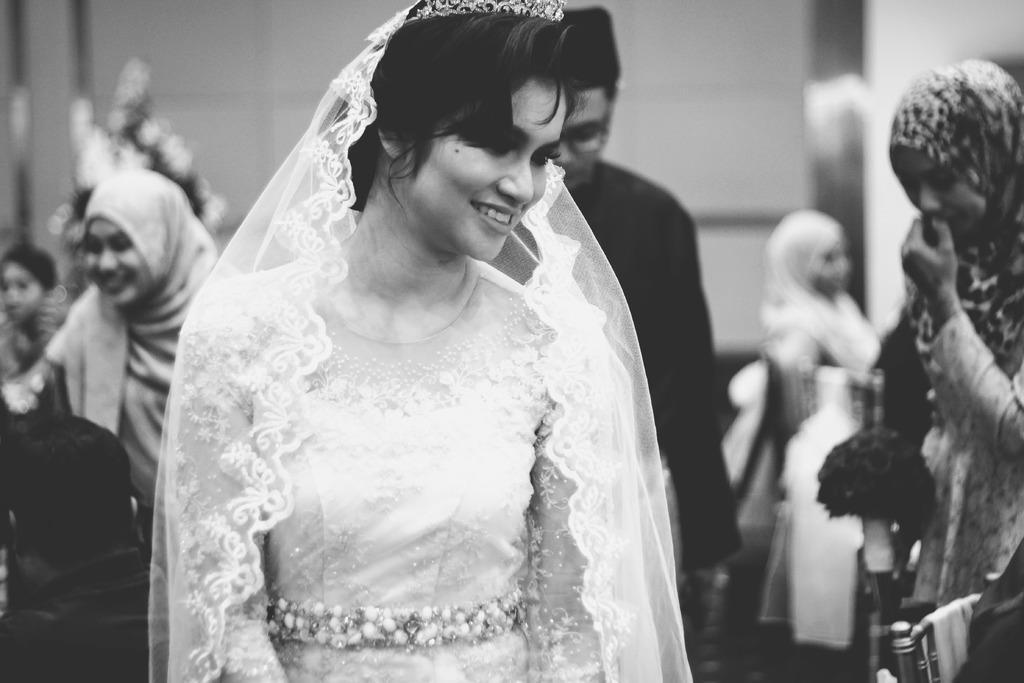Please provide a concise description of this image. This is a black and white image. We can see a woman with a veil. Behind the women, there are people and a blurred background. 